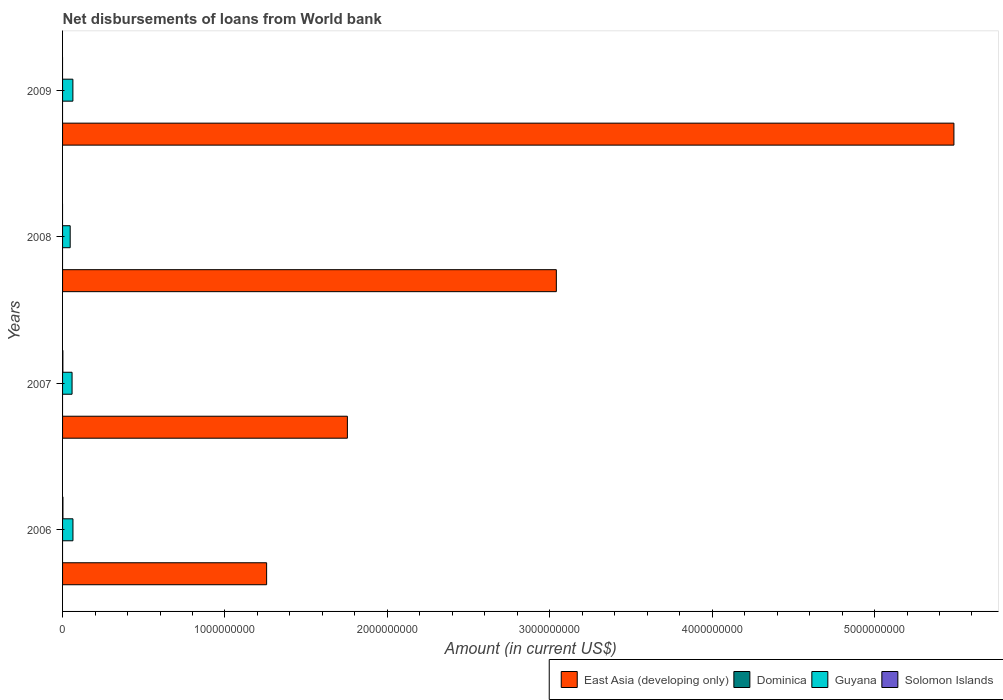How many different coloured bars are there?
Your answer should be compact. 3. Are the number of bars per tick equal to the number of legend labels?
Provide a short and direct response. No. Are the number of bars on each tick of the Y-axis equal?
Offer a very short reply. No. How many bars are there on the 4th tick from the top?
Your answer should be compact. 3. What is the label of the 3rd group of bars from the top?
Offer a very short reply. 2007. In how many cases, is the number of bars for a given year not equal to the number of legend labels?
Keep it short and to the point. 4. What is the amount of loan disbursed from World Bank in Guyana in 2006?
Keep it short and to the point. 6.40e+07. Across all years, what is the maximum amount of loan disbursed from World Bank in East Asia (developing only)?
Ensure brevity in your answer.  5.49e+09. Across all years, what is the minimum amount of loan disbursed from World Bank in Dominica?
Ensure brevity in your answer.  0. What is the total amount of loan disbursed from World Bank in Solomon Islands in the graph?
Provide a short and direct response. 4.22e+06. What is the difference between the amount of loan disbursed from World Bank in East Asia (developing only) in 2006 and that in 2009?
Provide a succinct answer. -4.23e+09. What is the difference between the amount of loan disbursed from World Bank in Guyana in 2009 and the amount of loan disbursed from World Bank in Dominica in 2008?
Offer a very short reply. 6.35e+07. What is the average amount of loan disbursed from World Bank in Guyana per year?
Ensure brevity in your answer.  5.82e+07. In the year 2007, what is the difference between the amount of loan disbursed from World Bank in Guyana and amount of loan disbursed from World Bank in East Asia (developing only)?
Provide a succinct answer. -1.70e+09. What is the ratio of the amount of loan disbursed from World Bank in East Asia (developing only) in 2007 to that in 2008?
Keep it short and to the point. 0.58. What is the difference between the highest and the second highest amount of loan disbursed from World Bank in Guyana?
Give a very brief answer. 4.57e+05. What is the difference between the highest and the lowest amount of loan disbursed from World Bank in Solomon Islands?
Your answer should be compact. 2.31e+06. What is the difference between two consecutive major ticks on the X-axis?
Your answer should be very brief. 1.00e+09. Are the values on the major ticks of X-axis written in scientific E-notation?
Your response must be concise. No. Does the graph contain any zero values?
Give a very brief answer. Yes. Does the graph contain grids?
Provide a succinct answer. No. Where does the legend appear in the graph?
Your answer should be compact. Bottom right. How are the legend labels stacked?
Make the answer very short. Horizontal. What is the title of the graph?
Your answer should be compact. Net disbursements of loans from World bank. Does "Sint Maarten (Dutch part)" appear as one of the legend labels in the graph?
Make the answer very short. No. What is the label or title of the X-axis?
Provide a succinct answer. Amount (in current US$). What is the Amount (in current US$) in East Asia (developing only) in 2006?
Provide a short and direct response. 1.26e+09. What is the Amount (in current US$) of Guyana in 2006?
Offer a terse response. 6.40e+07. What is the Amount (in current US$) of Solomon Islands in 2006?
Ensure brevity in your answer.  2.31e+06. What is the Amount (in current US$) of East Asia (developing only) in 2007?
Your answer should be very brief. 1.75e+09. What is the Amount (in current US$) of Dominica in 2007?
Provide a short and direct response. 0. What is the Amount (in current US$) of Guyana in 2007?
Make the answer very short. 5.84e+07. What is the Amount (in current US$) in Solomon Islands in 2007?
Your answer should be very brief. 1.91e+06. What is the Amount (in current US$) in East Asia (developing only) in 2008?
Ensure brevity in your answer.  3.04e+09. What is the Amount (in current US$) in Guyana in 2008?
Provide a succinct answer. 4.69e+07. What is the Amount (in current US$) of Solomon Islands in 2008?
Provide a succinct answer. 0. What is the Amount (in current US$) in East Asia (developing only) in 2009?
Your response must be concise. 5.49e+09. What is the Amount (in current US$) in Guyana in 2009?
Your answer should be very brief. 6.35e+07. What is the Amount (in current US$) in Solomon Islands in 2009?
Make the answer very short. 0. Across all years, what is the maximum Amount (in current US$) in East Asia (developing only)?
Your answer should be compact. 5.49e+09. Across all years, what is the maximum Amount (in current US$) of Guyana?
Make the answer very short. 6.40e+07. Across all years, what is the maximum Amount (in current US$) of Solomon Islands?
Give a very brief answer. 2.31e+06. Across all years, what is the minimum Amount (in current US$) in East Asia (developing only)?
Keep it short and to the point. 1.26e+09. Across all years, what is the minimum Amount (in current US$) in Guyana?
Ensure brevity in your answer.  4.69e+07. Across all years, what is the minimum Amount (in current US$) of Solomon Islands?
Keep it short and to the point. 0. What is the total Amount (in current US$) of East Asia (developing only) in the graph?
Keep it short and to the point. 1.15e+1. What is the total Amount (in current US$) in Guyana in the graph?
Your answer should be very brief. 2.33e+08. What is the total Amount (in current US$) of Solomon Islands in the graph?
Your answer should be very brief. 4.22e+06. What is the difference between the Amount (in current US$) of East Asia (developing only) in 2006 and that in 2007?
Your answer should be very brief. -4.97e+08. What is the difference between the Amount (in current US$) of Guyana in 2006 and that in 2007?
Keep it short and to the point. 5.56e+06. What is the difference between the Amount (in current US$) of Solomon Islands in 2006 and that in 2007?
Provide a short and direct response. 4.01e+05. What is the difference between the Amount (in current US$) of East Asia (developing only) in 2006 and that in 2008?
Make the answer very short. -1.78e+09. What is the difference between the Amount (in current US$) of Guyana in 2006 and that in 2008?
Make the answer very short. 1.71e+07. What is the difference between the Amount (in current US$) of East Asia (developing only) in 2006 and that in 2009?
Ensure brevity in your answer.  -4.23e+09. What is the difference between the Amount (in current US$) of Guyana in 2006 and that in 2009?
Provide a succinct answer. 4.57e+05. What is the difference between the Amount (in current US$) in East Asia (developing only) in 2007 and that in 2008?
Keep it short and to the point. -1.29e+09. What is the difference between the Amount (in current US$) in Guyana in 2007 and that in 2008?
Your response must be concise. 1.15e+07. What is the difference between the Amount (in current US$) of East Asia (developing only) in 2007 and that in 2009?
Offer a very short reply. -3.73e+09. What is the difference between the Amount (in current US$) of Guyana in 2007 and that in 2009?
Your response must be concise. -5.10e+06. What is the difference between the Amount (in current US$) in East Asia (developing only) in 2008 and that in 2009?
Your answer should be very brief. -2.45e+09. What is the difference between the Amount (in current US$) in Guyana in 2008 and that in 2009?
Keep it short and to the point. -1.66e+07. What is the difference between the Amount (in current US$) of East Asia (developing only) in 2006 and the Amount (in current US$) of Guyana in 2007?
Offer a terse response. 1.20e+09. What is the difference between the Amount (in current US$) of East Asia (developing only) in 2006 and the Amount (in current US$) of Solomon Islands in 2007?
Make the answer very short. 1.25e+09. What is the difference between the Amount (in current US$) in Guyana in 2006 and the Amount (in current US$) in Solomon Islands in 2007?
Your response must be concise. 6.21e+07. What is the difference between the Amount (in current US$) in East Asia (developing only) in 2006 and the Amount (in current US$) in Guyana in 2008?
Make the answer very short. 1.21e+09. What is the difference between the Amount (in current US$) in East Asia (developing only) in 2006 and the Amount (in current US$) in Guyana in 2009?
Offer a terse response. 1.19e+09. What is the difference between the Amount (in current US$) in East Asia (developing only) in 2007 and the Amount (in current US$) in Guyana in 2008?
Provide a short and direct response. 1.71e+09. What is the difference between the Amount (in current US$) in East Asia (developing only) in 2007 and the Amount (in current US$) in Guyana in 2009?
Provide a short and direct response. 1.69e+09. What is the difference between the Amount (in current US$) in East Asia (developing only) in 2008 and the Amount (in current US$) in Guyana in 2009?
Your answer should be compact. 2.98e+09. What is the average Amount (in current US$) of East Asia (developing only) per year?
Keep it short and to the point. 2.88e+09. What is the average Amount (in current US$) of Guyana per year?
Keep it short and to the point. 5.82e+07. What is the average Amount (in current US$) of Solomon Islands per year?
Keep it short and to the point. 1.06e+06. In the year 2006, what is the difference between the Amount (in current US$) in East Asia (developing only) and Amount (in current US$) in Guyana?
Offer a terse response. 1.19e+09. In the year 2006, what is the difference between the Amount (in current US$) of East Asia (developing only) and Amount (in current US$) of Solomon Islands?
Offer a very short reply. 1.25e+09. In the year 2006, what is the difference between the Amount (in current US$) of Guyana and Amount (in current US$) of Solomon Islands?
Make the answer very short. 6.17e+07. In the year 2007, what is the difference between the Amount (in current US$) of East Asia (developing only) and Amount (in current US$) of Guyana?
Make the answer very short. 1.70e+09. In the year 2007, what is the difference between the Amount (in current US$) of East Asia (developing only) and Amount (in current US$) of Solomon Islands?
Your answer should be compact. 1.75e+09. In the year 2007, what is the difference between the Amount (in current US$) in Guyana and Amount (in current US$) in Solomon Islands?
Offer a very short reply. 5.65e+07. In the year 2008, what is the difference between the Amount (in current US$) of East Asia (developing only) and Amount (in current US$) of Guyana?
Give a very brief answer. 2.99e+09. In the year 2009, what is the difference between the Amount (in current US$) in East Asia (developing only) and Amount (in current US$) in Guyana?
Provide a succinct answer. 5.43e+09. What is the ratio of the Amount (in current US$) of East Asia (developing only) in 2006 to that in 2007?
Keep it short and to the point. 0.72. What is the ratio of the Amount (in current US$) in Guyana in 2006 to that in 2007?
Your response must be concise. 1.1. What is the ratio of the Amount (in current US$) in Solomon Islands in 2006 to that in 2007?
Your answer should be compact. 1.21. What is the ratio of the Amount (in current US$) in East Asia (developing only) in 2006 to that in 2008?
Your response must be concise. 0.41. What is the ratio of the Amount (in current US$) in Guyana in 2006 to that in 2008?
Offer a very short reply. 1.36. What is the ratio of the Amount (in current US$) of East Asia (developing only) in 2006 to that in 2009?
Offer a very short reply. 0.23. What is the ratio of the Amount (in current US$) in Guyana in 2006 to that in 2009?
Your answer should be very brief. 1.01. What is the ratio of the Amount (in current US$) of East Asia (developing only) in 2007 to that in 2008?
Offer a terse response. 0.58. What is the ratio of the Amount (in current US$) in Guyana in 2007 to that in 2008?
Provide a short and direct response. 1.25. What is the ratio of the Amount (in current US$) in East Asia (developing only) in 2007 to that in 2009?
Your answer should be very brief. 0.32. What is the ratio of the Amount (in current US$) in Guyana in 2007 to that in 2009?
Offer a terse response. 0.92. What is the ratio of the Amount (in current US$) of East Asia (developing only) in 2008 to that in 2009?
Provide a short and direct response. 0.55. What is the ratio of the Amount (in current US$) of Guyana in 2008 to that in 2009?
Offer a very short reply. 0.74. What is the difference between the highest and the second highest Amount (in current US$) of East Asia (developing only)?
Give a very brief answer. 2.45e+09. What is the difference between the highest and the second highest Amount (in current US$) in Guyana?
Make the answer very short. 4.57e+05. What is the difference between the highest and the lowest Amount (in current US$) in East Asia (developing only)?
Keep it short and to the point. 4.23e+09. What is the difference between the highest and the lowest Amount (in current US$) of Guyana?
Provide a short and direct response. 1.71e+07. What is the difference between the highest and the lowest Amount (in current US$) in Solomon Islands?
Provide a succinct answer. 2.31e+06. 